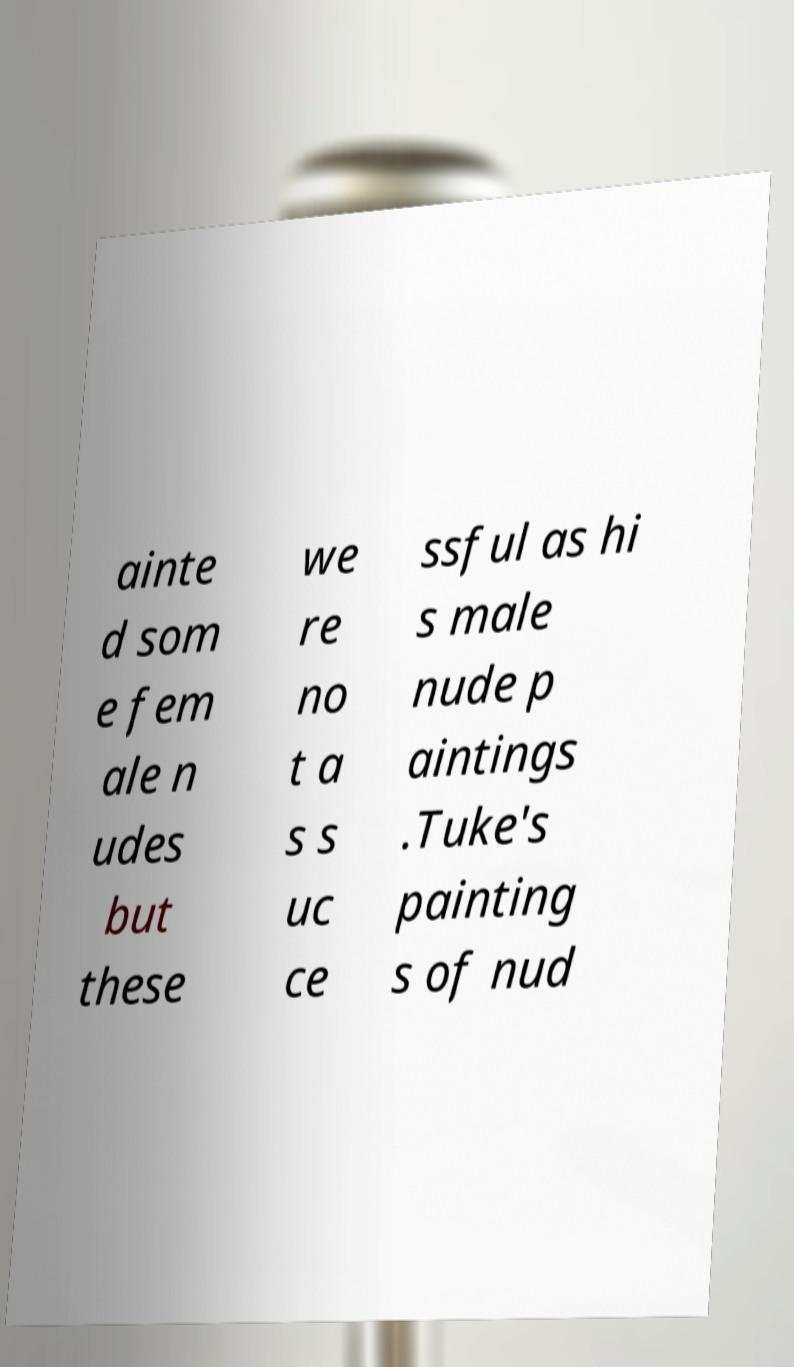Could you extract and type out the text from this image? ainte d som e fem ale n udes but these we re no t a s s uc ce ssful as hi s male nude p aintings .Tuke's painting s of nud 